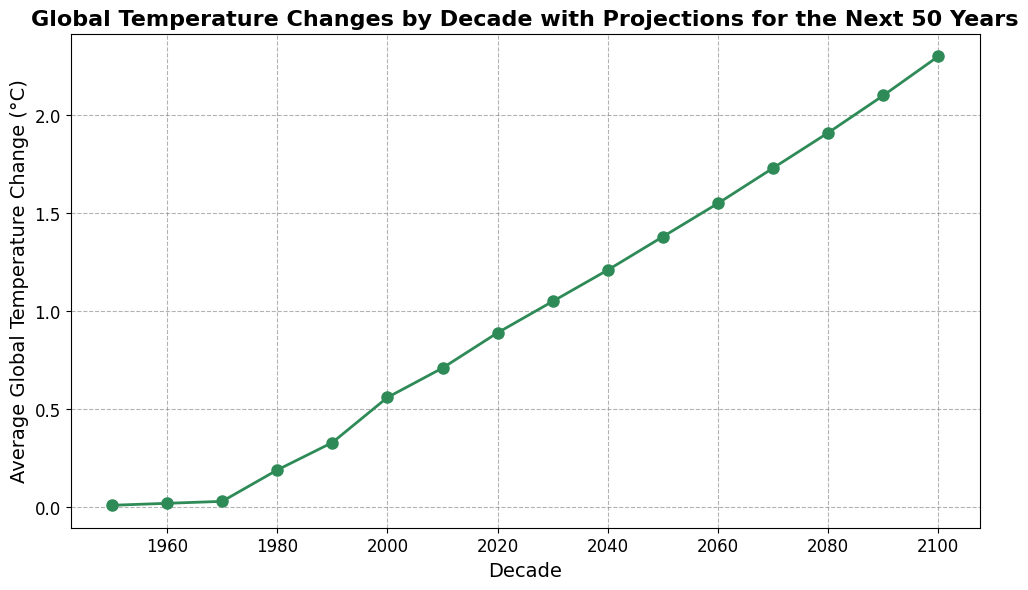What is the average global temperature change for the decades between 1950 and 2000? Sum the temperature changes for the decades 1950 to 2000: (0.01 + 0.02 + 0.03 + 0.19 + 0.33 + 0.56) = 1.14. Divide by the number of decades (6): 1.14 / 6 = 0.19
Answer: 0.19 Which decade has the highest projected temperature change? Identify the highest value from 2020 to 2100: The highest value is 2.30°C in 2100
Answer: 2100 How much did the average global temperature change increase from 1980 to 2020? Subtract the average global temperature change in 1980 from that in 2020: 0.89 - 0.19 = 0.70
Answer: 0.70 Compare the temperature change between 1950 and 2020. By how much did it increase? Subtract the temperature change in 1950 from the change in 2020: 0.89 - 0.01 = 0.88
Answer: 0.88 What is the visual color of the line representing temperature changes? The line representing temperature changes is colored in seagreen according to the code provided in the description.
Answer: Seagreen Between which decades does the most significant increase in average temperature change occur? Identify the pairs of decades with the largest difference: The largest increase is between 1970 (0.03) and 1980 (0.19). The change is 0.19 - 0.03 = 0.16
Answer: 1970 and 1980 Predict the average temperature change in 2050 based on the figure. From the data points, the predicted average temperature change for 2050 is 1.38°C, as shown by the corresponding value on the line chart.
Answer: 1.38 What is the total sum of the projected temperature changes from 2030 to 2100? Sum the projected changes: 1.05 + 1.21 + 1.38 + 1.55 + 1.73 + 1.91 + 2.10 + 2.30 = 12.23
Answer: 12.23 What trend can be observed about the average global temperature changes over the decades presented in the figure? The trend shows a steady increase in temperature changes over the decades, with more pronounced increases starting from the 1980s and continuing into future projections.
Answer: Steady increase 